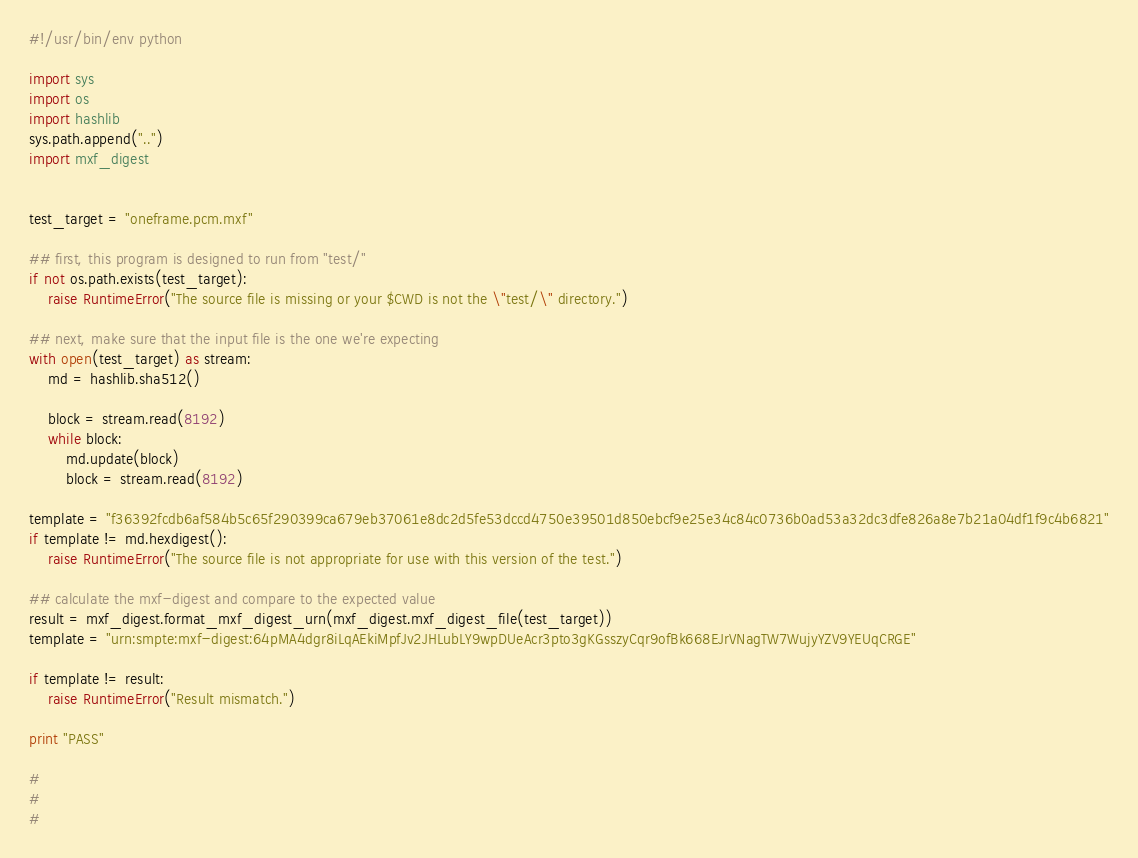<code> <loc_0><loc_0><loc_500><loc_500><_Python_>#!/usr/bin/env python

import sys
import os
import hashlib
sys.path.append("..")
import mxf_digest


test_target = "oneframe.pcm.mxf"

## first, this program is designed to run from "test/"
if not os.path.exists(test_target):
    raise RuntimeError("The source file is missing or your $CWD is not the \"test/\" directory.")

## next, make sure that the input file is the one we're expecting
with open(test_target) as stream:
    md = hashlib.sha512()

    block = stream.read(8192)
    while block:
        md.update(block)
        block = stream.read(8192)

template = "f36392fcdb6af584b5c65f290399ca679eb37061e8dc2d5fe53dccd4750e39501d850ebcf9e25e34c84c0736b0ad53a32dc3dfe826a8e7b21a04df1f9c4b6821"
if template != md.hexdigest():
    raise RuntimeError("The source file is not appropriate for use with this version of the test.")

## calculate the mxf-digest and compare to the expected value
result = mxf_digest.format_mxf_digest_urn(mxf_digest.mxf_digest_file(test_target))
template = "urn:smpte:mxf-digest:64pMA4dgr8iLqAEkiMpfJv2JHLubLY9wpDUeAcr3pto3gKGsszyCqr9ofBk668EJrVNagTW7WujyYZV9YEUqCRGE"

if template != result:
    raise RuntimeError("Result mismatch.")

print "PASS"

#
#
#
</code> 